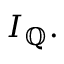<formula> <loc_0><loc_0><loc_500><loc_500>I _ { \mathbb { Q } } .</formula> 